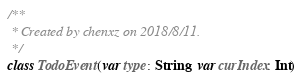Convert code to text. <code><loc_0><loc_0><loc_500><loc_500><_Kotlin_>/**
 * Created by chenxz on 2018/8/11.
 */
class TodoEvent(var type: String, var curIndex: Int)</code> 